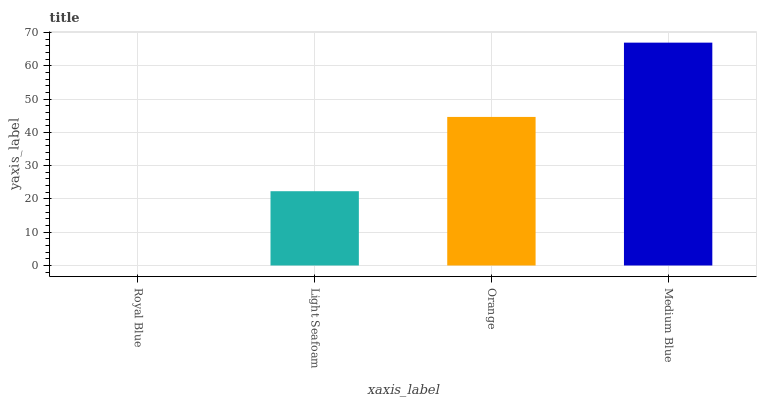Is Royal Blue the minimum?
Answer yes or no. Yes. Is Medium Blue the maximum?
Answer yes or no. Yes. Is Light Seafoam the minimum?
Answer yes or no. No. Is Light Seafoam the maximum?
Answer yes or no. No. Is Light Seafoam greater than Royal Blue?
Answer yes or no. Yes. Is Royal Blue less than Light Seafoam?
Answer yes or no. Yes. Is Royal Blue greater than Light Seafoam?
Answer yes or no. No. Is Light Seafoam less than Royal Blue?
Answer yes or no. No. Is Orange the high median?
Answer yes or no. Yes. Is Light Seafoam the low median?
Answer yes or no. Yes. Is Royal Blue the high median?
Answer yes or no. No. Is Royal Blue the low median?
Answer yes or no. No. 